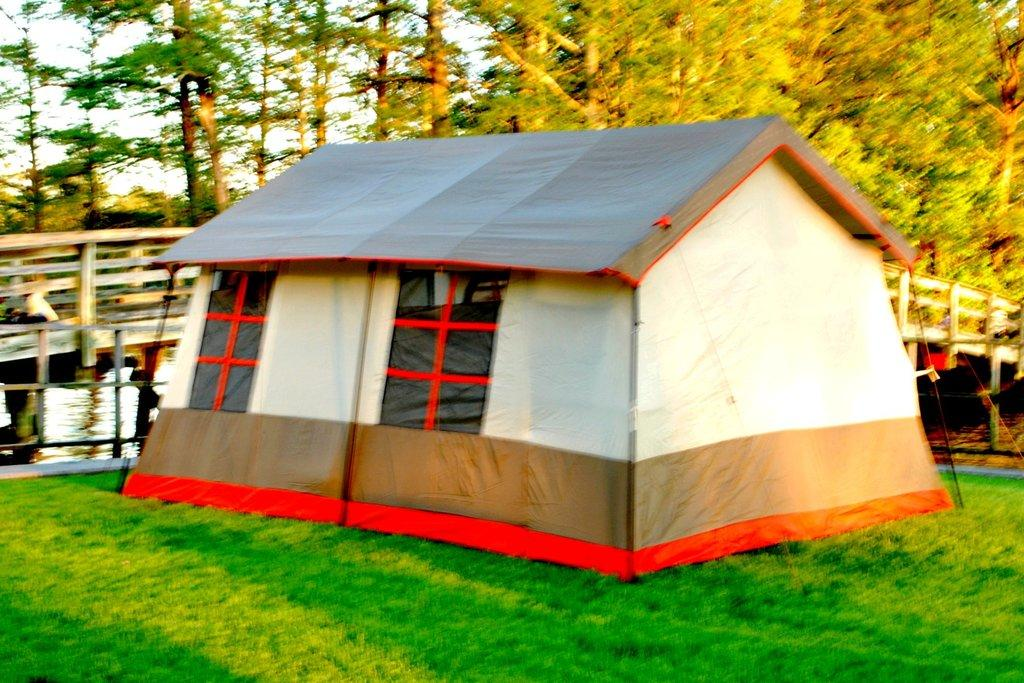What type of shelter is visible in the image? There is a tent in the image. What natural elements can be seen in the image? There are trees and grass present in the image. What man-made structure is visible in the image? There is a bridge in the image. Where is the cactus located in the image? There is no cactus present in the image. What type of prison can be seen in the image? There is no prison present in the image. 